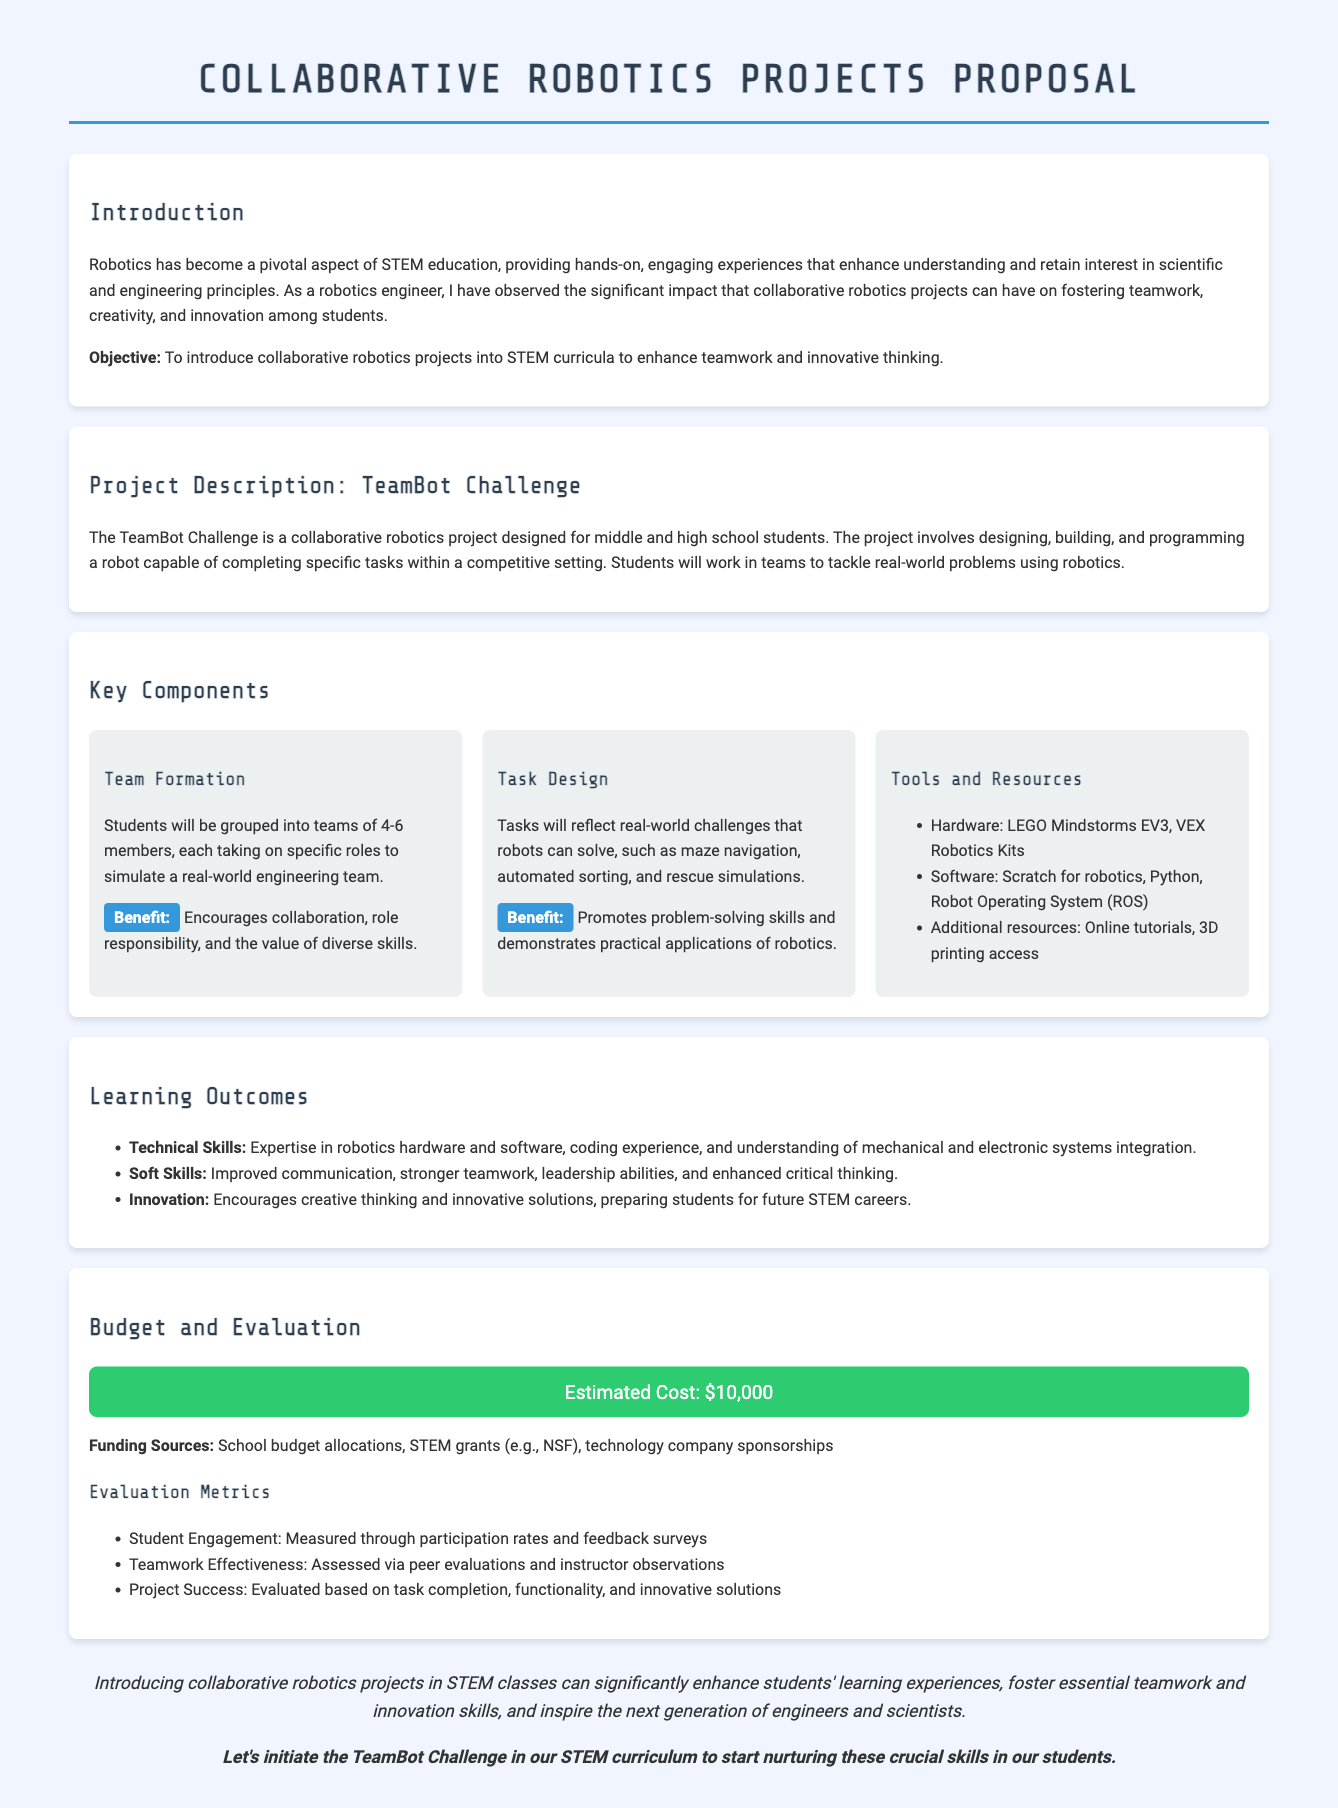What is the main objective of the proposal? The objective of the proposal is to introduce collaborative robotics projects into STEM curricula to enhance teamwork and innovative thinking.
Answer: To enhance teamwork and innovative thinking What is the name of the project described in the proposal? The project described in the proposal is called the TeamBot Challenge.
Answer: TeamBot Challenge How many members will each team consist of? Each team will consist of 4-6 members.
Answer: 4-6 members What is the estimated cost of the project? The estimated cost of the project is mentioned in the budget section, which is $10,000.
Answer: $10,000 What type of hardware is included in the project? The hardware included in the project consists of LEGO Mindstorms EV3 and VEX Robotics Kits.
Answer: LEGO Mindstorms EV3, VEX Robotics Kits How will student engagement be measured? Student engagement will be measured through participation rates and feedback surveys.
Answer: Participation rates and feedback surveys What skills are improved through this project? Improved skills include communication, teamwork, leadership, and critical thinking.
Answer: Communication, teamwork, leadership, and critical thinking What is one of the benefits of task design in the project? One benefit of task design is that it promotes problem-solving skills and demonstrates practical applications of robotics.
Answer: Promotes problem-solving skills What is a potential funding source mentioned in the proposal? The proposal mentions school budget allocations as a potential funding source.
Answer: School budget allocations 